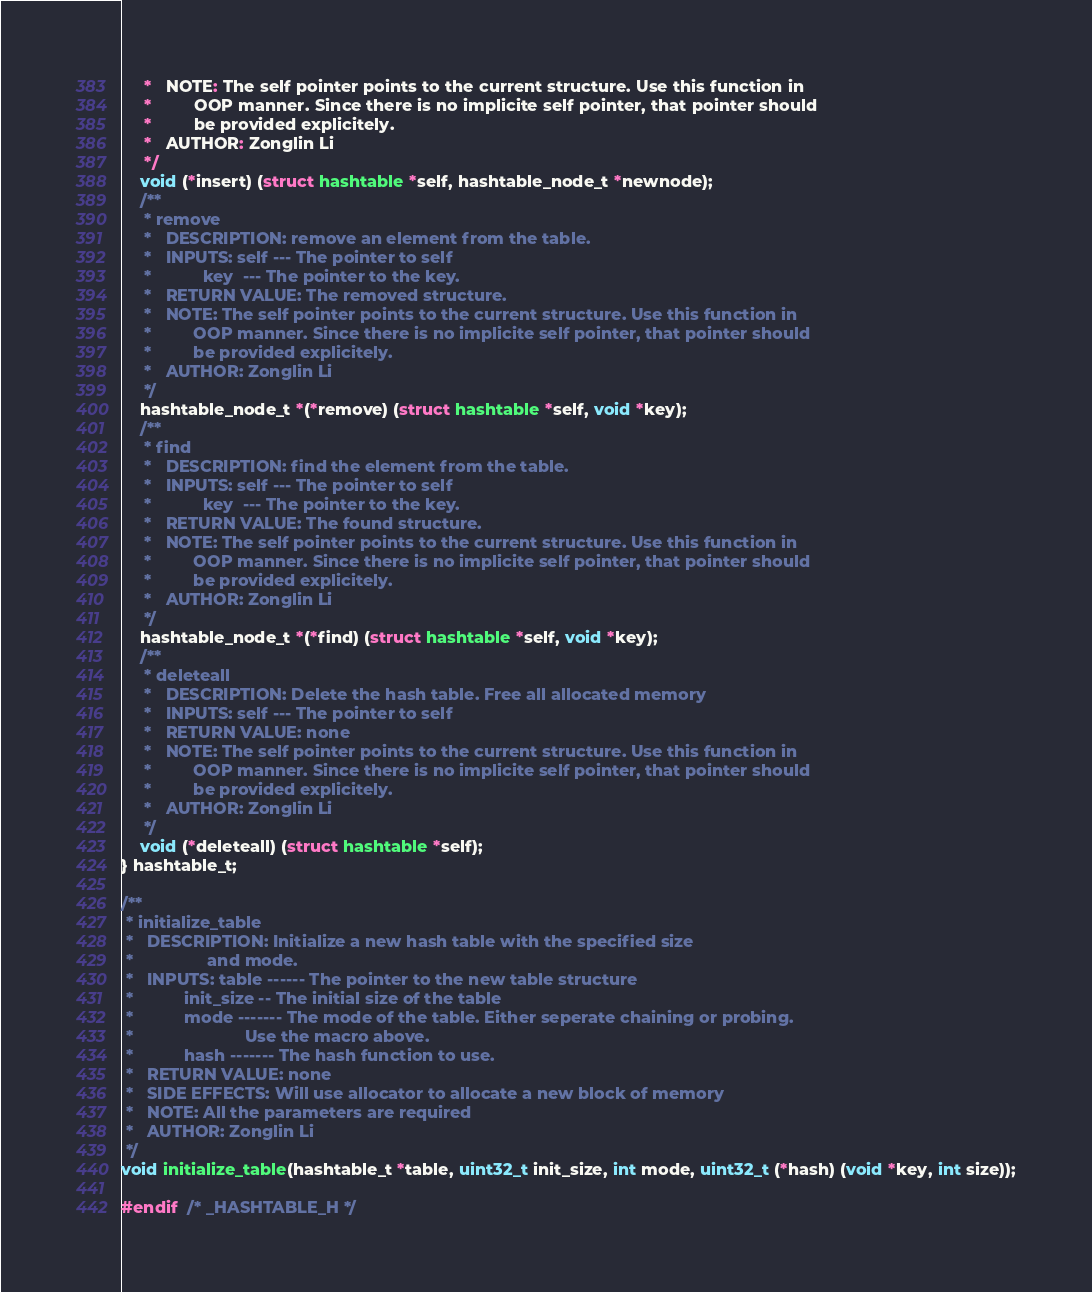Convert code to text. <code><loc_0><loc_0><loc_500><loc_500><_C_>     *   NOTE: The self pointer points to the current structure. Use this function in 
     *         OOP manner. Since there is no implicite self pointer, that pointer should
     *         be provided explicitely.
     *   AUTHOR: Zonglin Li
     */
    void (*insert) (struct hashtable *self, hashtable_node_t *newnode);
    /**
     * remove
     *   DESCRIPTION: remove an element from the table.
     *   INPUTS: self --- The pointer to self
     *           key  --- The pointer to the key.
     *   RETURN VALUE: The removed structure.
     *   NOTE: The self pointer points to the current structure. Use this function in 
     *         OOP manner. Since there is no implicite self pointer, that pointer should
     *         be provided explicitely.
     *   AUTHOR: Zonglin Li
     */
    hashtable_node_t *(*remove) (struct hashtable *self, void *key);
    /**
     * find
     *   DESCRIPTION: find the element from the table.
     *   INPUTS: self --- The pointer to self
     *           key  --- The pointer to the key.
     *   RETURN VALUE: The found structure.
     *   NOTE: The self pointer points to the current structure. Use this function in 
     *         OOP manner. Since there is no implicite self pointer, that pointer should
     *         be provided explicitely.
     *   AUTHOR: Zonglin Li
     */
    hashtable_node_t *(*find) (struct hashtable *self, void *key);
    /**
     * deleteall
     *   DESCRIPTION: Delete the hash table. Free all allocated memory
     *   INPUTS: self --- The pointer to self
     *   RETURN VALUE: none
     *   NOTE: The self pointer points to the current structure. Use this function in 
     *         OOP manner. Since there is no implicite self pointer, that pointer should
     *         be provided explicitely.
     *   AUTHOR: Zonglin Li
     */
    void (*deleteall) (struct hashtable *self);
} hashtable_t;

/**
 * initialize_table
 *   DESCRIPTION: Initialize a new hash table with the specified size
 *                and mode.
 *   INPUTS: table ------ The pointer to the new table structure
 *           init_size -- The initial size of the table
 *           mode ------- The mode of the table. Either seperate chaining or probing. 
 *                        Use the macro above.
 *           hash ------- The hash function to use.
 *   RETURN VALUE: none
 *   SIDE EFFECTS: Will use allocator to allocate a new block of memory 
 *   NOTE: All the parameters are required
 *   AUTHOR: Zonglin Li
 */
void initialize_table(hashtable_t *table, uint32_t init_size, int mode, uint32_t (*hash) (void *key, int size));

#endif  /* _HASHTABLE_H */

</code> 